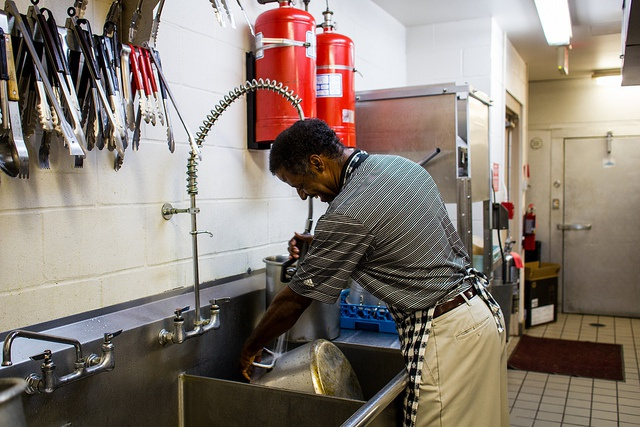Describe the objects in this image and their specific colors. I can see people in darkgray, black, tan, and gray tones, sink in darkgray, black, and gray tones, refrigerator in darkgray, gray, and lightgray tones, bowl in darkgray, gray, black, tan, and olive tones, and spoon in darkgray, black, gray, and tan tones in this image. 